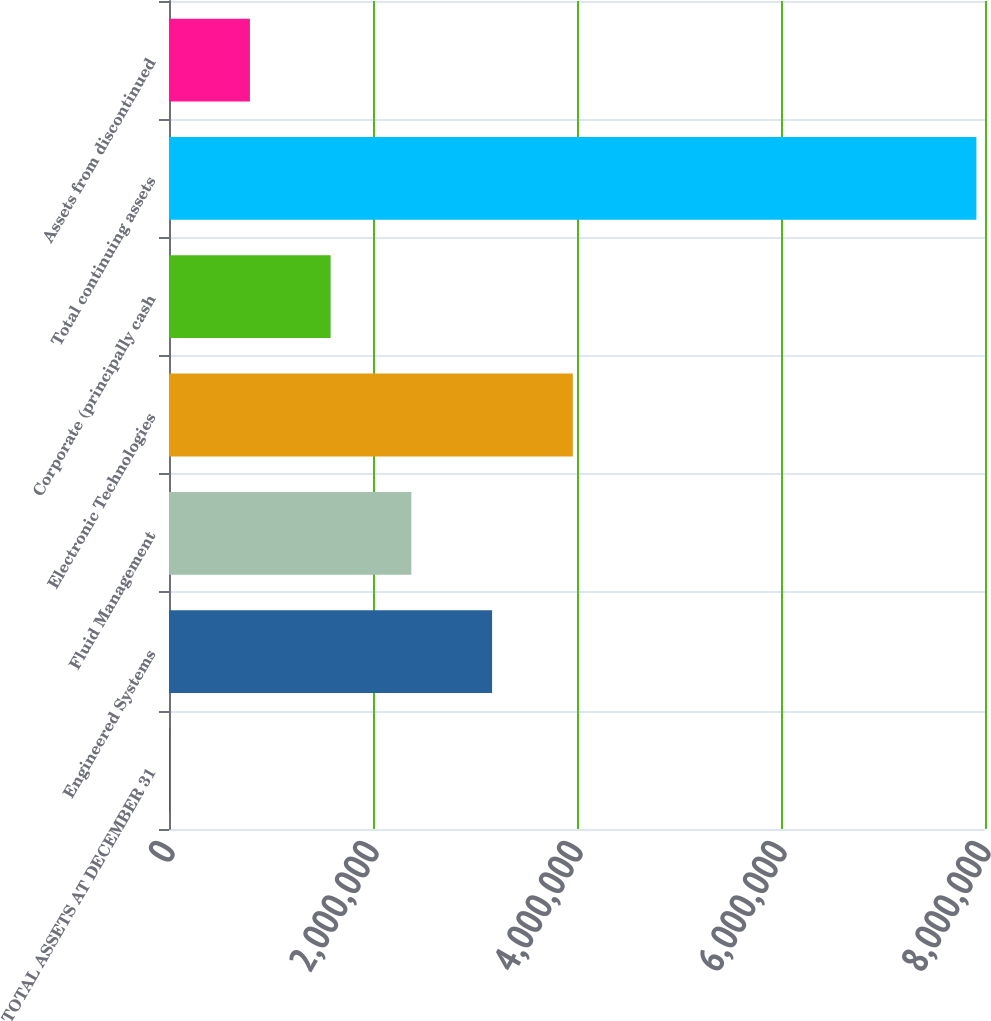Convert chart to OTSL. <chart><loc_0><loc_0><loc_500><loc_500><bar_chart><fcel>TOTAL ASSETS AT DECEMBER 31<fcel>Engineered Systems<fcel>Fluid Management<fcel>Electronic Technologies<fcel>Corporate (principally cash<fcel>Total continuing assets<fcel>Assets from discontinued<nl><fcel>2007<fcel>3.16746e+06<fcel>2.3761e+06<fcel>3.95883e+06<fcel>1.58474e+06<fcel>7.91565e+06<fcel>793371<nl></chart> 